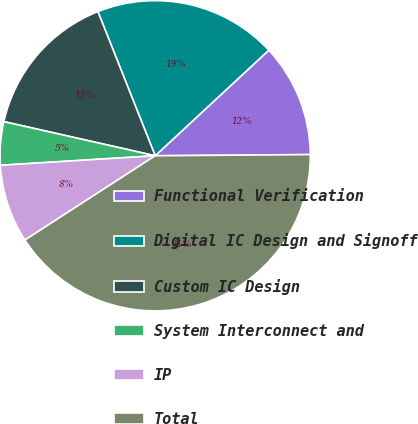<chart> <loc_0><loc_0><loc_500><loc_500><pie_chart><fcel>Functional Verification<fcel>Digital IC Design and Signoff<fcel>Custom IC Design<fcel>System Interconnect and<fcel>IP<fcel>Total<nl><fcel>11.8%<fcel>19.1%<fcel>15.45%<fcel>4.51%<fcel>8.16%<fcel>40.98%<nl></chart> 